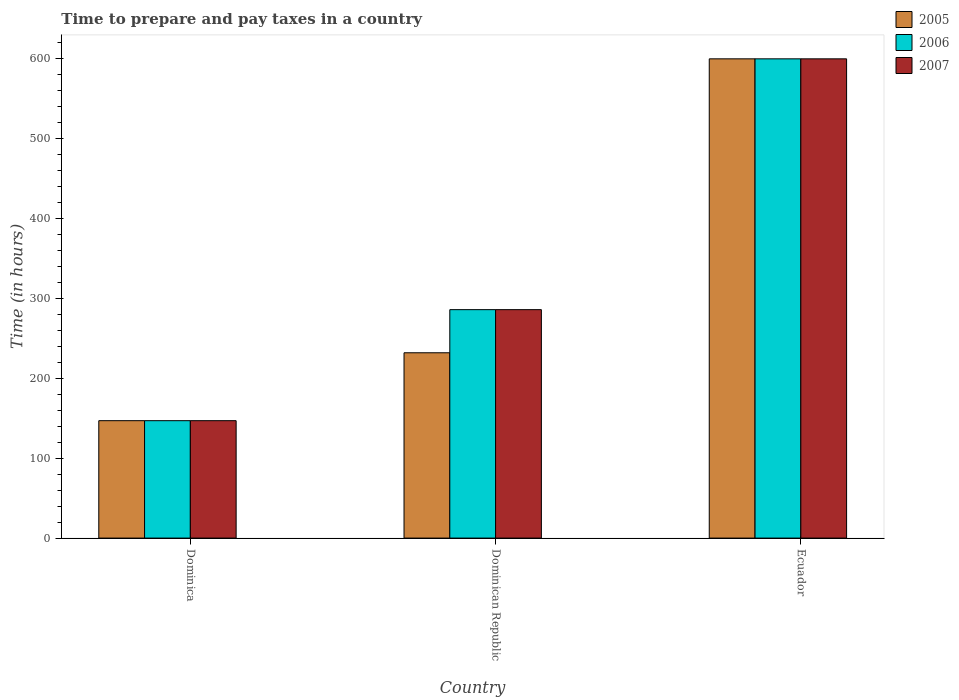How many different coloured bars are there?
Provide a short and direct response. 3. How many groups of bars are there?
Your response must be concise. 3. Are the number of bars per tick equal to the number of legend labels?
Provide a short and direct response. Yes. Are the number of bars on each tick of the X-axis equal?
Your response must be concise. Yes. What is the label of the 2nd group of bars from the left?
Provide a short and direct response. Dominican Republic. In how many cases, is the number of bars for a given country not equal to the number of legend labels?
Provide a succinct answer. 0. What is the number of hours required to prepare and pay taxes in 2006 in Ecuador?
Offer a very short reply. 600. Across all countries, what is the maximum number of hours required to prepare and pay taxes in 2007?
Offer a very short reply. 600. Across all countries, what is the minimum number of hours required to prepare and pay taxes in 2007?
Make the answer very short. 147. In which country was the number of hours required to prepare and pay taxes in 2005 maximum?
Make the answer very short. Ecuador. In which country was the number of hours required to prepare and pay taxes in 2006 minimum?
Your response must be concise. Dominica. What is the total number of hours required to prepare and pay taxes in 2006 in the graph?
Make the answer very short. 1033. What is the difference between the number of hours required to prepare and pay taxes in 2007 in Dominica and that in Ecuador?
Offer a terse response. -453. What is the difference between the number of hours required to prepare and pay taxes in 2005 in Dominican Republic and the number of hours required to prepare and pay taxes in 2006 in Ecuador?
Offer a very short reply. -368. What is the average number of hours required to prepare and pay taxes in 2005 per country?
Offer a terse response. 326.33. What is the ratio of the number of hours required to prepare and pay taxes in 2006 in Dominica to that in Dominican Republic?
Give a very brief answer. 0.51. Is the difference between the number of hours required to prepare and pay taxes in 2007 in Dominica and Dominican Republic greater than the difference between the number of hours required to prepare and pay taxes in 2005 in Dominica and Dominican Republic?
Keep it short and to the point. No. What is the difference between the highest and the second highest number of hours required to prepare and pay taxes in 2005?
Ensure brevity in your answer.  368. What is the difference between the highest and the lowest number of hours required to prepare and pay taxes in 2007?
Make the answer very short. 453. Is the sum of the number of hours required to prepare and pay taxes in 2007 in Dominican Republic and Ecuador greater than the maximum number of hours required to prepare and pay taxes in 2005 across all countries?
Give a very brief answer. Yes. What does the 1st bar from the left in Dominica represents?
Make the answer very short. 2005. How many countries are there in the graph?
Provide a short and direct response. 3. What is the difference between two consecutive major ticks on the Y-axis?
Provide a succinct answer. 100. Are the values on the major ticks of Y-axis written in scientific E-notation?
Keep it short and to the point. No. Does the graph contain any zero values?
Your answer should be compact. No. Does the graph contain grids?
Your answer should be very brief. No. Where does the legend appear in the graph?
Provide a succinct answer. Top right. How many legend labels are there?
Offer a terse response. 3. How are the legend labels stacked?
Make the answer very short. Vertical. What is the title of the graph?
Provide a short and direct response. Time to prepare and pay taxes in a country. What is the label or title of the Y-axis?
Your answer should be very brief. Time (in hours). What is the Time (in hours) of 2005 in Dominica?
Your response must be concise. 147. What is the Time (in hours) of 2006 in Dominica?
Give a very brief answer. 147. What is the Time (in hours) of 2007 in Dominica?
Make the answer very short. 147. What is the Time (in hours) of 2005 in Dominican Republic?
Provide a short and direct response. 232. What is the Time (in hours) of 2006 in Dominican Republic?
Keep it short and to the point. 286. What is the Time (in hours) in 2007 in Dominican Republic?
Offer a terse response. 286. What is the Time (in hours) in 2005 in Ecuador?
Give a very brief answer. 600. What is the Time (in hours) in 2006 in Ecuador?
Your response must be concise. 600. What is the Time (in hours) of 2007 in Ecuador?
Your response must be concise. 600. Across all countries, what is the maximum Time (in hours) of 2005?
Ensure brevity in your answer.  600. Across all countries, what is the maximum Time (in hours) of 2006?
Provide a succinct answer. 600. Across all countries, what is the maximum Time (in hours) in 2007?
Offer a very short reply. 600. Across all countries, what is the minimum Time (in hours) in 2005?
Your response must be concise. 147. Across all countries, what is the minimum Time (in hours) in 2006?
Offer a very short reply. 147. Across all countries, what is the minimum Time (in hours) in 2007?
Your response must be concise. 147. What is the total Time (in hours) of 2005 in the graph?
Provide a short and direct response. 979. What is the total Time (in hours) of 2006 in the graph?
Offer a terse response. 1033. What is the total Time (in hours) of 2007 in the graph?
Offer a very short reply. 1033. What is the difference between the Time (in hours) in 2005 in Dominica and that in Dominican Republic?
Your answer should be very brief. -85. What is the difference between the Time (in hours) of 2006 in Dominica and that in Dominican Republic?
Give a very brief answer. -139. What is the difference between the Time (in hours) in 2007 in Dominica and that in Dominican Republic?
Provide a succinct answer. -139. What is the difference between the Time (in hours) of 2005 in Dominica and that in Ecuador?
Offer a terse response. -453. What is the difference between the Time (in hours) in 2006 in Dominica and that in Ecuador?
Provide a short and direct response. -453. What is the difference between the Time (in hours) in 2007 in Dominica and that in Ecuador?
Give a very brief answer. -453. What is the difference between the Time (in hours) of 2005 in Dominican Republic and that in Ecuador?
Your answer should be very brief. -368. What is the difference between the Time (in hours) of 2006 in Dominican Republic and that in Ecuador?
Your response must be concise. -314. What is the difference between the Time (in hours) of 2007 in Dominican Republic and that in Ecuador?
Keep it short and to the point. -314. What is the difference between the Time (in hours) in 2005 in Dominica and the Time (in hours) in 2006 in Dominican Republic?
Provide a succinct answer. -139. What is the difference between the Time (in hours) in 2005 in Dominica and the Time (in hours) in 2007 in Dominican Republic?
Ensure brevity in your answer.  -139. What is the difference between the Time (in hours) in 2006 in Dominica and the Time (in hours) in 2007 in Dominican Republic?
Your answer should be compact. -139. What is the difference between the Time (in hours) of 2005 in Dominica and the Time (in hours) of 2006 in Ecuador?
Your answer should be very brief. -453. What is the difference between the Time (in hours) of 2005 in Dominica and the Time (in hours) of 2007 in Ecuador?
Keep it short and to the point. -453. What is the difference between the Time (in hours) of 2006 in Dominica and the Time (in hours) of 2007 in Ecuador?
Make the answer very short. -453. What is the difference between the Time (in hours) of 2005 in Dominican Republic and the Time (in hours) of 2006 in Ecuador?
Provide a succinct answer. -368. What is the difference between the Time (in hours) in 2005 in Dominican Republic and the Time (in hours) in 2007 in Ecuador?
Keep it short and to the point. -368. What is the difference between the Time (in hours) in 2006 in Dominican Republic and the Time (in hours) in 2007 in Ecuador?
Your answer should be very brief. -314. What is the average Time (in hours) of 2005 per country?
Give a very brief answer. 326.33. What is the average Time (in hours) of 2006 per country?
Offer a terse response. 344.33. What is the average Time (in hours) of 2007 per country?
Your answer should be very brief. 344.33. What is the difference between the Time (in hours) of 2005 and Time (in hours) of 2006 in Dominica?
Provide a short and direct response. 0. What is the difference between the Time (in hours) in 2005 and Time (in hours) in 2006 in Dominican Republic?
Ensure brevity in your answer.  -54. What is the difference between the Time (in hours) in 2005 and Time (in hours) in 2007 in Dominican Republic?
Provide a short and direct response. -54. What is the difference between the Time (in hours) of 2005 and Time (in hours) of 2006 in Ecuador?
Make the answer very short. 0. What is the ratio of the Time (in hours) in 2005 in Dominica to that in Dominican Republic?
Provide a short and direct response. 0.63. What is the ratio of the Time (in hours) of 2006 in Dominica to that in Dominican Republic?
Your answer should be compact. 0.51. What is the ratio of the Time (in hours) of 2007 in Dominica to that in Dominican Republic?
Provide a short and direct response. 0.51. What is the ratio of the Time (in hours) in 2005 in Dominica to that in Ecuador?
Give a very brief answer. 0.24. What is the ratio of the Time (in hours) in 2006 in Dominica to that in Ecuador?
Provide a succinct answer. 0.24. What is the ratio of the Time (in hours) of 2007 in Dominica to that in Ecuador?
Ensure brevity in your answer.  0.24. What is the ratio of the Time (in hours) in 2005 in Dominican Republic to that in Ecuador?
Provide a short and direct response. 0.39. What is the ratio of the Time (in hours) of 2006 in Dominican Republic to that in Ecuador?
Provide a succinct answer. 0.48. What is the ratio of the Time (in hours) of 2007 in Dominican Republic to that in Ecuador?
Offer a terse response. 0.48. What is the difference between the highest and the second highest Time (in hours) in 2005?
Give a very brief answer. 368. What is the difference between the highest and the second highest Time (in hours) of 2006?
Give a very brief answer. 314. What is the difference between the highest and the second highest Time (in hours) in 2007?
Your answer should be very brief. 314. What is the difference between the highest and the lowest Time (in hours) in 2005?
Keep it short and to the point. 453. What is the difference between the highest and the lowest Time (in hours) of 2006?
Make the answer very short. 453. What is the difference between the highest and the lowest Time (in hours) of 2007?
Offer a very short reply. 453. 